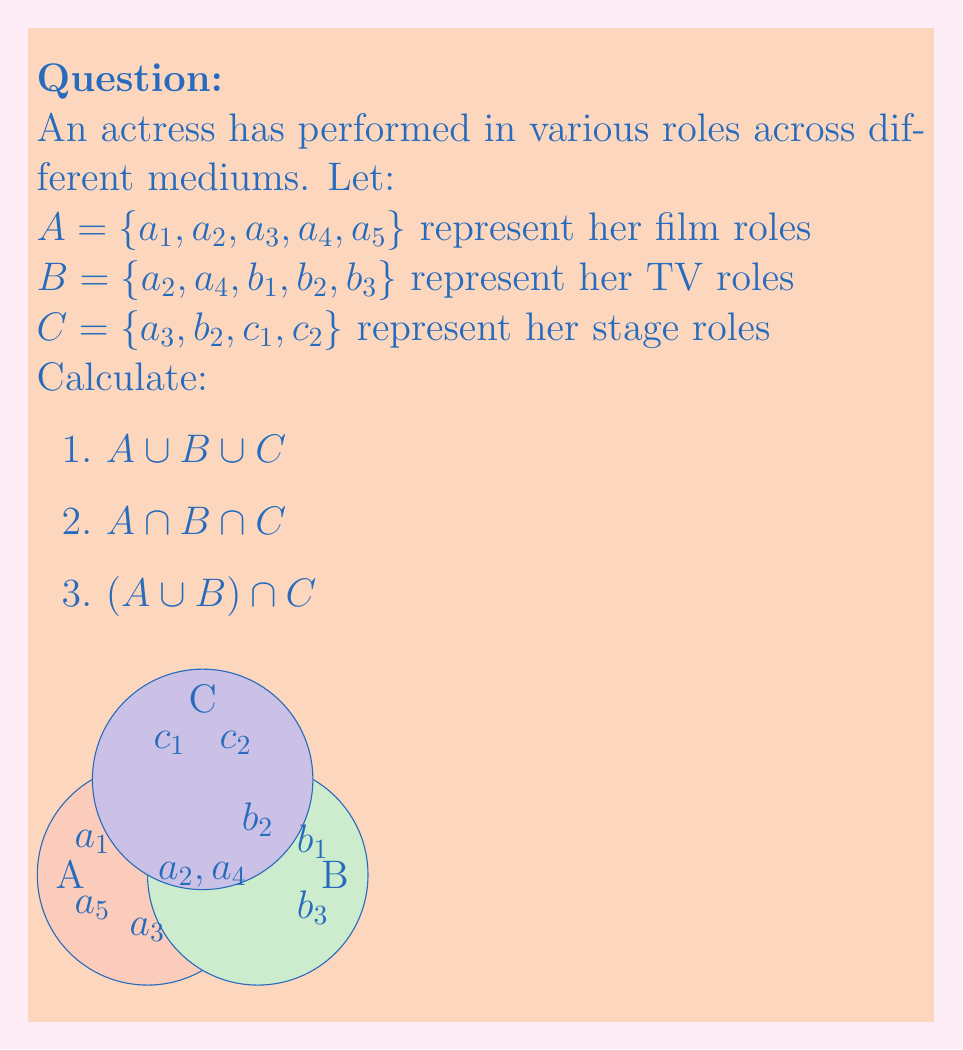Can you solve this math problem? Let's approach this step-by-step:

1) To find $A \cup B \cup C$, we list all unique elements from all sets:
   $A \cup B \cup C = \{a_1, a_2, a_3, a_4, a_5, b_1, b_2, b_3, c_1, c_2\}$
   This represents all roles the actress has performed across film, TV, and stage.

2) To find $A \cap B \cap C$, we identify elements common to all three sets:
   $A \cap B \cap C = \{\}$ (empty set)
   There are no roles that appear in all three mediums.

3) To find $(A \cup B) \cap C$:
   First, we calculate $A \cup B$:
   $A \cup B = \{a_1, a_2, a_3, a_4, a_5, b_1, b_2, b_3\}$
   
   Then, we find the intersection of this with $C$:
   $(A \cup B) \cap C = \{a_3, b_2\}$
   These are the stage roles that the actress has also performed in either film or TV.
Answer: 1) $\{a_1, a_2, a_3, a_4, a_5, b_1, b_2, b_3, c_1, c_2\}$
2) $\{\}$
3) $\{a_3, b_2\}$ 